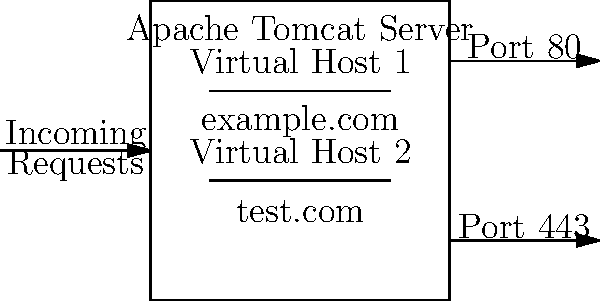Given the network diagram of an Apache Tomcat server configuration with multiple virtual hosts, which configuration file should be modified to set up these virtual hosts, and what key elements need to be included for each virtual host? To configure multiple virtual hosts in Apache Tomcat, follow these steps:

1. Locate the server configuration file:
   The main configuration file for Apache Tomcat is `server.xml`, typically found in the `conf` directory of your Tomcat installation.

2. Add `<Host>` elements:
   Inside the `<Engine>` element of `server.xml`, add separate `<Host>` elements for each virtual host.

3. Configure each `<Host>` element:
   For each virtual host, include the following key attributes and child elements:
   a. `name`: Set this to the domain name (e.g., "example.com" or "test.com")
   b. `appBase`: Specify the directory for the web applications (e.g., "webapps/example" or "webapps/test")
   c. `unpackWARs`: Set to "true" to automatically unpack WAR files
   d. `autoDeploy`: Set to "true" for automatic deployment of web applications

4. Add `<Alias>` elements:
   If needed, include `<Alias>` elements to define additional domain names for each virtual host.

5. Configure `<Context>` elements:
   Within each `<Host>`, add `<Context>` elements to define the context path and document base for each web application.

6. Set up SSL (if using HTTPS):
   If using port 443 for HTTPS, configure an SSL connector in the `server.xml` file and ensure proper certificate setup.

7. Update DNS or hosts file:
   Ensure that the domain names resolve to the server's IP address.

8. Restart Tomcat:
   After making changes to `server.xml`, restart the Tomcat server for the changes to take effect.

By following these steps and properly configuring the `server.xml` file, you can set up multiple virtual hosts as shown in the network diagram.
Answer: Modify server.xml, include <Host> elements with name, appBase, unpackWARs, autoDeploy, <Alias>, and <Context> for each virtual host. 